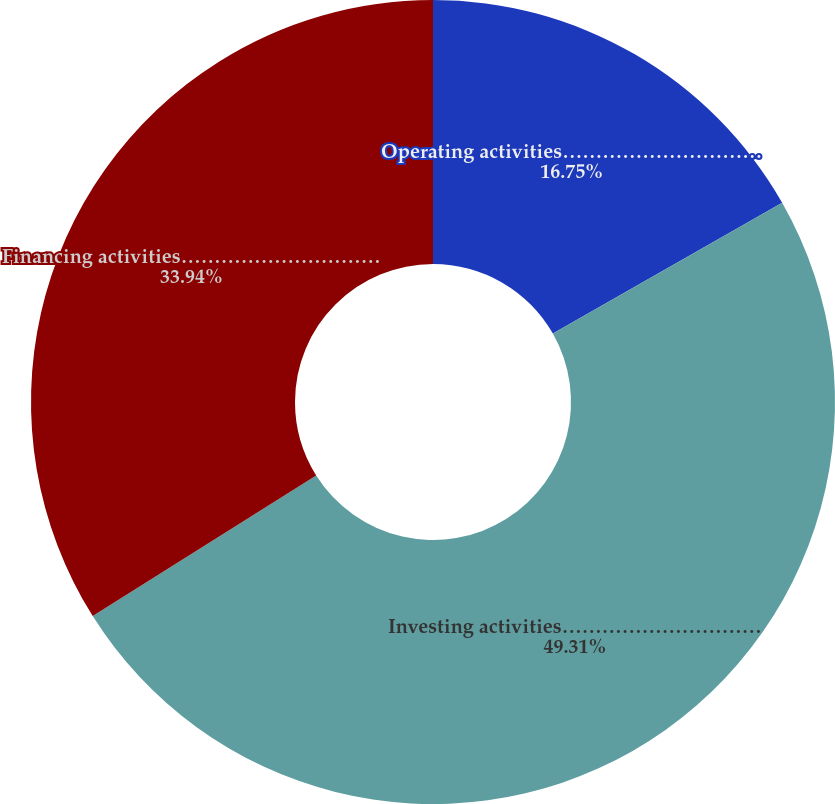Convert chart. <chart><loc_0><loc_0><loc_500><loc_500><pie_chart><fcel>Operating activities…………………………<fcel>Investing activities…………………………<fcel>Financing activities…………………………<nl><fcel>16.75%<fcel>49.32%<fcel>33.94%<nl></chart> 